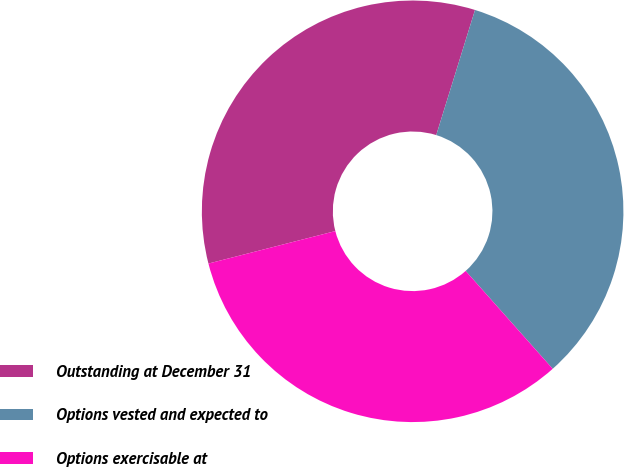<chart> <loc_0><loc_0><loc_500><loc_500><pie_chart><fcel>Outstanding at December 31<fcel>Options vested and expected to<fcel>Options exercisable at<nl><fcel>33.77%<fcel>33.65%<fcel>32.58%<nl></chart> 